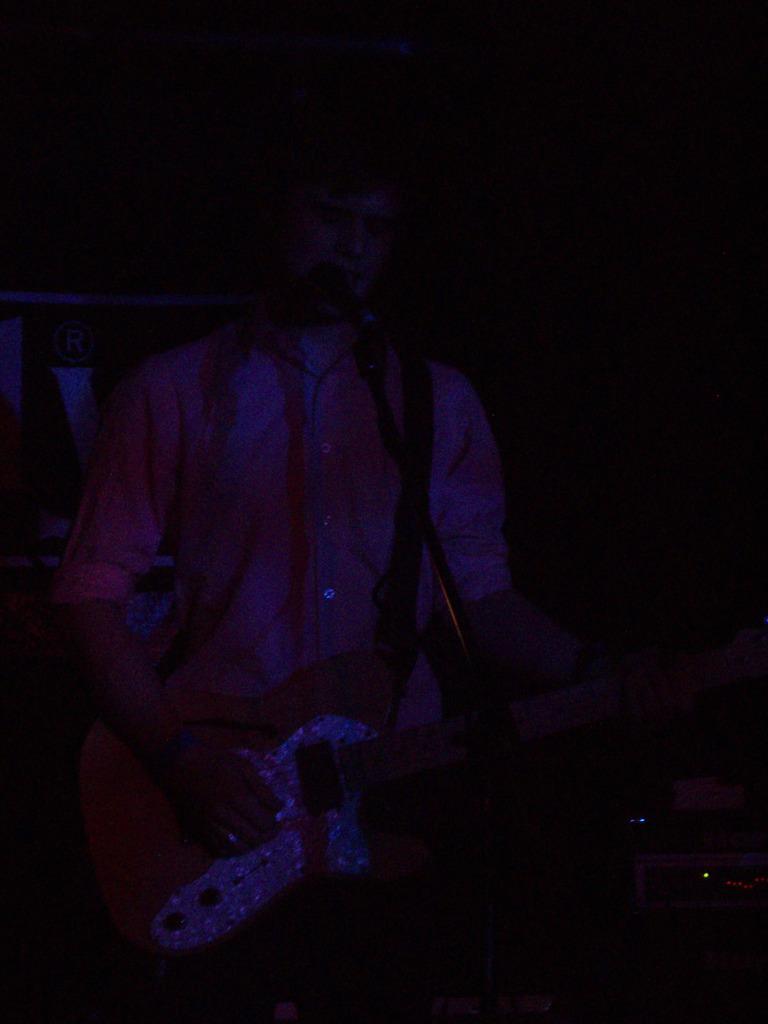How would you summarize this image in a sentence or two? In this image, we can see a man playing a guitar in front of a microphone. In the background, we can see a black color. 